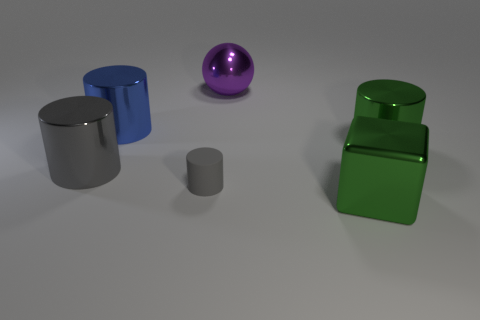Add 3 matte spheres. How many objects exist? 9 Subtract all gray rubber cylinders. How many cylinders are left? 3 Subtract all green cylinders. How many cylinders are left? 3 Subtract 4 cylinders. How many cylinders are left? 0 Subtract all large metal cylinders. Subtract all cyan balls. How many objects are left? 3 Add 5 tiny gray matte cylinders. How many tiny gray matte cylinders are left? 6 Add 4 brown cubes. How many brown cubes exist? 4 Subtract 1 blue cylinders. How many objects are left? 5 Subtract all spheres. How many objects are left? 5 Subtract all gray blocks. Subtract all cyan spheres. How many blocks are left? 1 